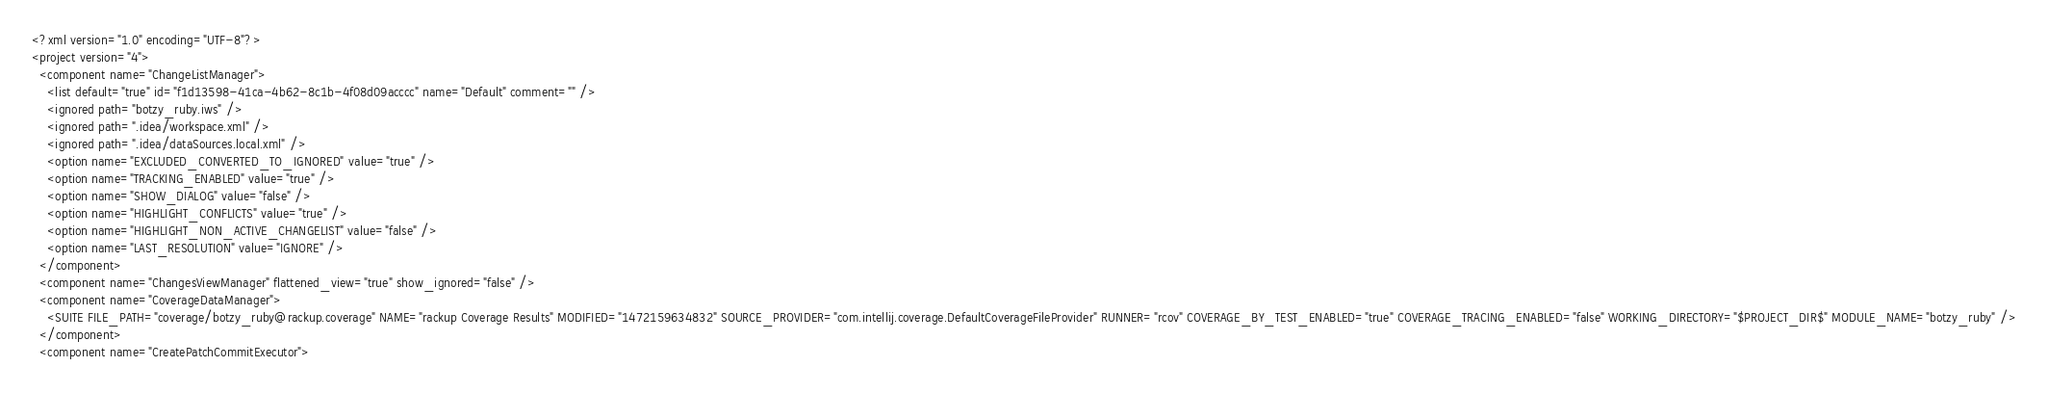<code> <loc_0><loc_0><loc_500><loc_500><_XML_><?xml version="1.0" encoding="UTF-8"?>
<project version="4">
  <component name="ChangeListManager">
    <list default="true" id="f1d13598-41ca-4b62-8c1b-4f08d09acccc" name="Default" comment="" />
    <ignored path="botzy_ruby.iws" />
    <ignored path=".idea/workspace.xml" />
    <ignored path=".idea/dataSources.local.xml" />
    <option name="EXCLUDED_CONVERTED_TO_IGNORED" value="true" />
    <option name="TRACKING_ENABLED" value="true" />
    <option name="SHOW_DIALOG" value="false" />
    <option name="HIGHLIGHT_CONFLICTS" value="true" />
    <option name="HIGHLIGHT_NON_ACTIVE_CHANGELIST" value="false" />
    <option name="LAST_RESOLUTION" value="IGNORE" />
  </component>
  <component name="ChangesViewManager" flattened_view="true" show_ignored="false" />
  <component name="CoverageDataManager">
    <SUITE FILE_PATH="coverage/botzy_ruby@rackup.coverage" NAME="rackup Coverage Results" MODIFIED="1472159634832" SOURCE_PROVIDER="com.intellij.coverage.DefaultCoverageFileProvider" RUNNER="rcov" COVERAGE_BY_TEST_ENABLED="true" COVERAGE_TRACING_ENABLED="false" WORKING_DIRECTORY="$PROJECT_DIR$" MODULE_NAME="botzy_ruby" />
  </component>
  <component name="CreatePatchCommitExecutor"></code> 